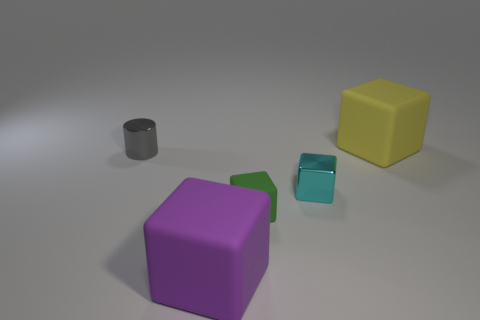Subtract 1 cubes. How many cubes are left? 3 Add 1 small cyan metal objects. How many objects exist? 6 Subtract all blocks. How many objects are left? 1 Subtract all big purple metallic cylinders. Subtract all metallic cubes. How many objects are left? 4 Add 2 small cyan cubes. How many small cyan cubes are left? 3 Add 3 green rubber things. How many green rubber things exist? 4 Subtract 0 yellow spheres. How many objects are left? 5 